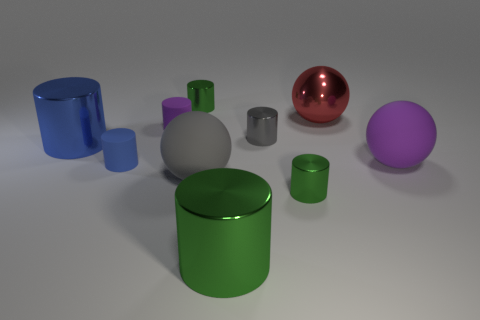What material is the gray object that is in front of the metallic thing that is left of the blue object in front of the blue metallic cylinder?
Your answer should be very brief. Rubber. What number of other objects are there of the same size as the gray cylinder?
Your answer should be very brief. 4. Is the number of small purple things that are in front of the blue shiny object greater than the number of green rubber spheres?
Offer a very short reply. No. Are there any tiny matte cylinders of the same color as the large metallic sphere?
Your response must be concise. No. What color is the shiny cylinder that is the same size as the blue shiny thing?
Offer a terse response. Green. What number of small purple objects are on the right side of the green thing that is behind the large gray rubber sphere?
Your answer should be compact. 0. What number of objects are either things on the right side of the big blue object or tiny red metal cylinders?
Your answer should be compact. 9. What number of other large gray things are the same material as the large gray object?
Make the answer very short. 0. Is the number of gray rubber things in front of the large gray rubber object the same as the number of cyan balls?
Give a very brief answer. Yes. What is the size of the green metal cylinder that is behind the large gray object?
Make the answer very short. Small. 